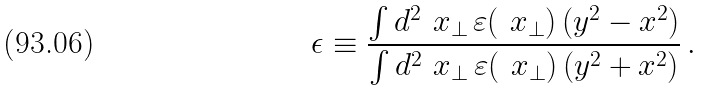Convert formula to latex. <formula><loc_0><loc_0><loc_500><loc_500>\epsilon \equiv \frac { \int d ^ { 2 } \ x _ { \perp } \, \varepsilon ( \ x _ { \perp } ) \, ( y ^ { 2 } - x ^ { 2 } ) } { \int d ^ { 2 } \ x _ { \perp } \, \varepsilon ( \ x _ { \perp } ) \, ( y ^ { 2 } + x ^ { 2 } ) } \, .</formula> 